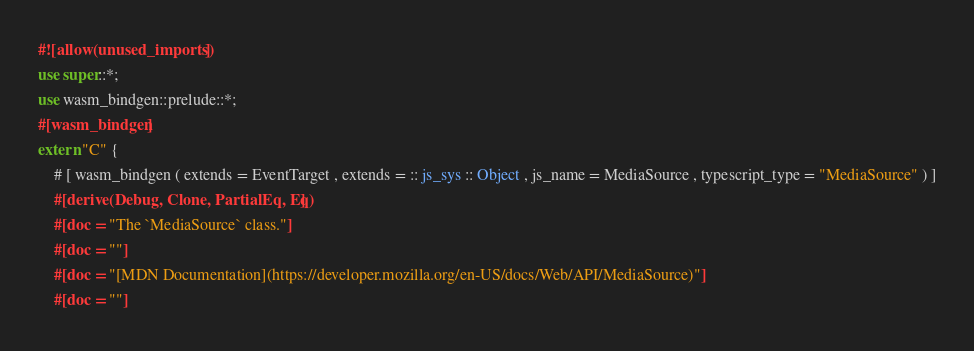<code> <loc_0><loc_0><loc_500><loc_500><_Rust_>#![allow(unused_imports)]
use super::*;
use wasm_bindgen::prelude::*;
#[wasm_bindgen]
extern "C" {
    # [ wasm_bindgen ( extends = EventTarget , extends = :: js_sys :: Object , js_name = MediaSource , typescript_type = "MediaSource" ) ]
    #[derive(Debug, Clone, PartialEq, Eq)]
    #[doc = "The `MediaSource` class."]
    #[doc = ""]
    #[doc = "[MDN Documentation](https://developer.mozilla.org/en-US/docs/Web/API/MediaSource)"]
    #[doc = ""]</code> 